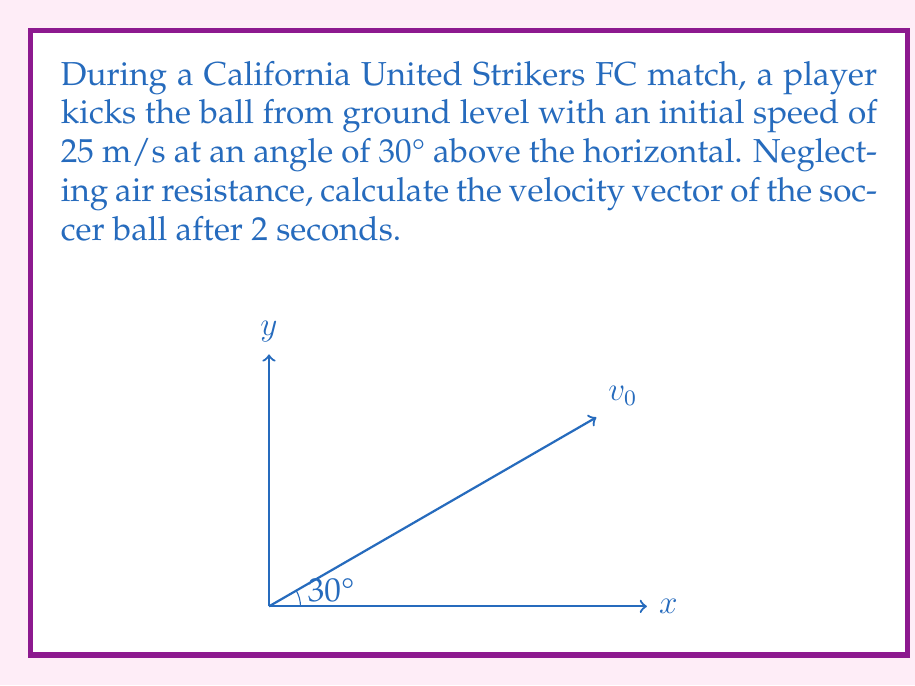Can you solve this math problem? To solve this problem, we'll use the equations of motion for projectile motion:

1) For the x-component (horizontal):
   $v_x = v_0 \cos \theta$
   $x = v_0 t \cos \theta$

2) For the y-component (vertical):
   $v_y = v_0 \sin \theta - gt$
   $y = v_0 t \sin \theta - \frac{1}{2}gt^2$

Where:
$v_0 = 25$ m/s (initial speed)
$\theta = 30°$ (angle above horizontal)
$g = 9.8$ m/s² (acceleration due to gravity)
$t = 2$ s (time after kick)

Step 1: Calculate the x-component of velocity
$v_x = v_0 \cos \theta = 25 \cos 30° = 25 \cdot \frac{\sqrt{3}}{2} = 21.65$ m/s

Step 2: Calculate the y-component of velocity
$v_y = v_0 \sin \theta - gt = 25 \sin 30° - 9.8 \cdot 2$
$v_y = 25 \cdot \frac{1}{2} - 19.6 = -7.1$ m/s

Step 3: Express the velocity vector
The velocity vector after 2 seconds is:

$$\vec{v} = (21.65\hat{i} - 7.1\hat{j})$$ m/s

Where $\hat{i}$ is the unit vector in the x-direction and $\hat{j}$ is the unit vector in the y-direction.
Answer: $\vec{v} = (21.65\hat{i} - 7.1\hat{j})$ m/s 